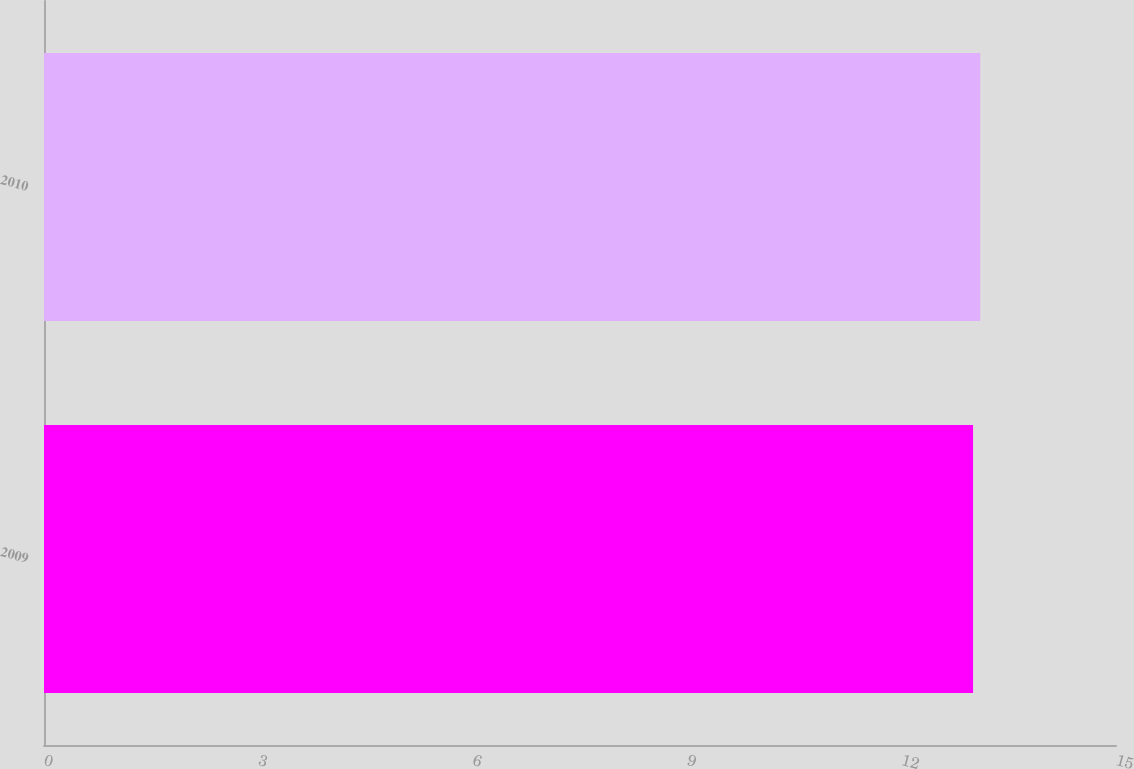Convert chart. <chart><loc_0><loc_0><loc_500><loc_500><bar_chart><fcel>2009<fcel>2010<nl><fcel>13<fcel>13.1<nl></chart> 